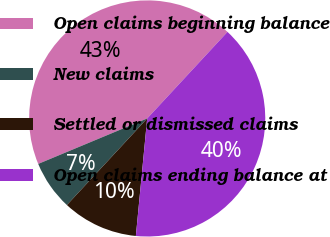Convert chart to OTSL. <chart><loc_0><loc_0><loc_500><loc_500><pie_chart><fcel>Open claims beginning balance<fcel>New claims<fcel>Settled or dismissed claims<fcel>Open claims ending balance at<nl><fcel>43.19%<fcel>6.81%<fcel>10.37%<fcel>39.63%<nl></chart> 